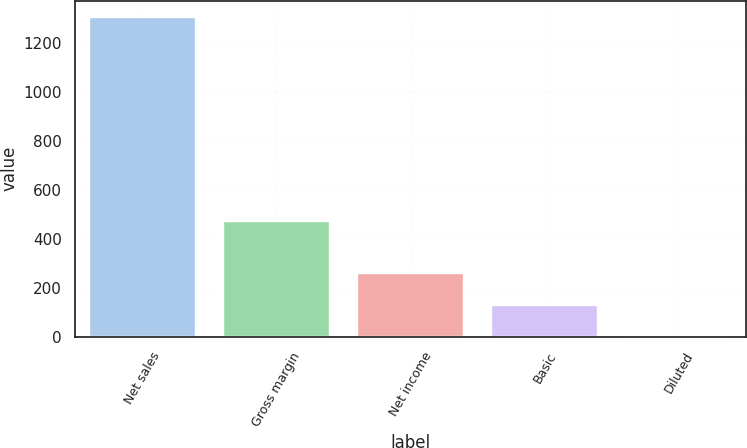<chart> <loc_0><loc_0><loc_500><loc_500><bar_chart><fcel>Net sales<fcel>Gross margin<fcel>Net income<fcel>Basic<fcel>Diluted<nl><fcel>1306.4<fcel>471.7<fcel>261.43<fcel>130.81<fcel>0.19<nl></chart> 